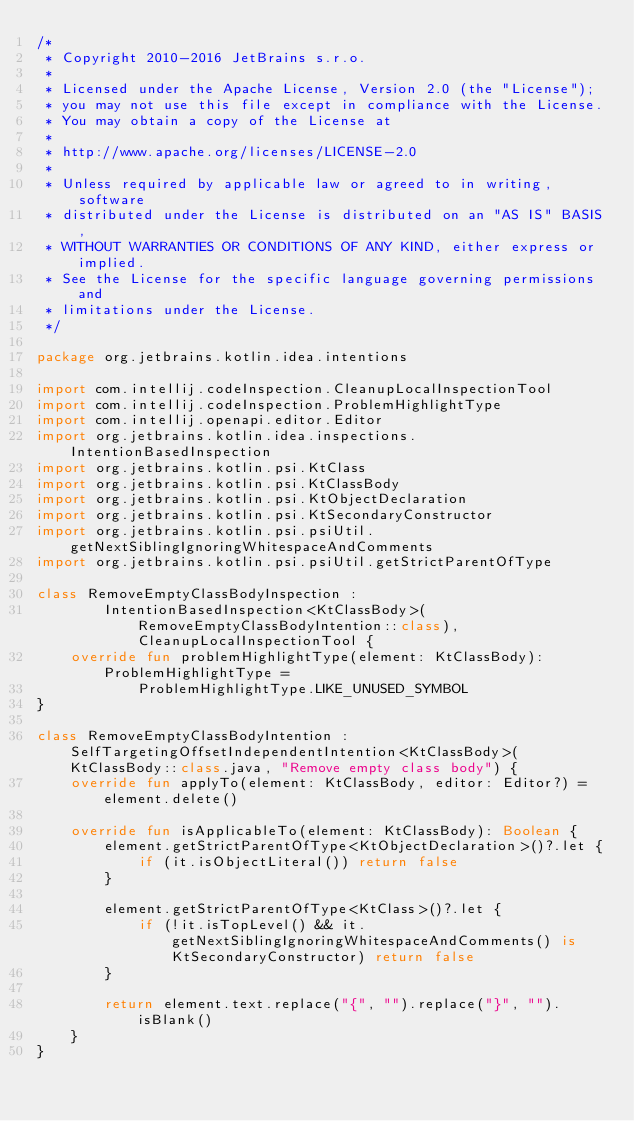<code> <loc_0><loc_0><loc_500><loc_500><_Kotlin_>/*
 * Copyright 2010-2016 JetBrains s.r.o.
 *
 * Licensed under the Apache License, Version 2.0 (the "License");
 * you may not use this file except in compliance with the License.
 * You may obtain a copy of the License at
 *
 * http://www.apache.org/licenses/LICENSE-2.0
 *
 * Unless required by applicable law or agreed to in writing, software
 * distributed under the License is distributed on an "AS IS" BASIS,
 * WITHOUT WARRANTIES OR CONDITIONS OF ANY KIND, either express or implied.
 * See the License for the specific language governing permissions and
 * limitations under the License.
 */

package org.jetbrains.kotlin.idea.intentions

import com.intellij.codeInspection.CleanupLocalInspectionTool
import com.intellij.codeInspection.ProblemHighlightType
import com.intellij.openapi.editor.Editor
import org.jetbrains.kotlin.idea.inspections.IntentionBasedInspection
import org.jetbrains.kotlin.psi.KtClass
import org.jetbrains.kotlin.psi.KtClassBody
import org.jetbrains.kotlin.psi.KtObjectDeclaration
import org.jetbrains.kotlin.psi.KtSecondaryConstructor
import org.jetbrains.kotlin.psi.psiUtil.getNextSiblingIgnoringWhitespaceAndComments
import org.jetbrains.kotlin.psi.psiUtil.getStrictParentOfType

class RemoveEmptyClassBodyInspection :
        IntentionBasedInspection<KtClassBody>(RemoveEmptyClassBodyIntention::class), CleanupLocalInspectionTool {
    override fun problemHighlightType(element: KtClassBody): ProblemHighlightType =
            ProblemHighlightType.LIKE_UNUSED_SYMBOL
}

class RemoveEmptyClassBodyIntention : SelfTargetingOffsetIndependentIntention<KtClassBody>(KtClassBody::class.java, "Remove empty class body") {
    override fun applyTo(element: KtClassBody, editor: Editor?) = element.delete()

    override fun isApplicableTo(element: KtClassBody): Boolean {
        element.getStrictParentOfType<KtObjectDeclaration>()?.let {
            if (it.isObjectLiteral()) return false
        }

        element.getStrictParentOfType<KtClass>()?.let {
            if (!it.isTopLevel() && it.getNextSiblingIgnoringWhitespaceAndComments() is KtSecondaryConstructor) return false
        }

        return element.text.replace("{", "").replace("}", "").isBlank()
    }
}</code> 